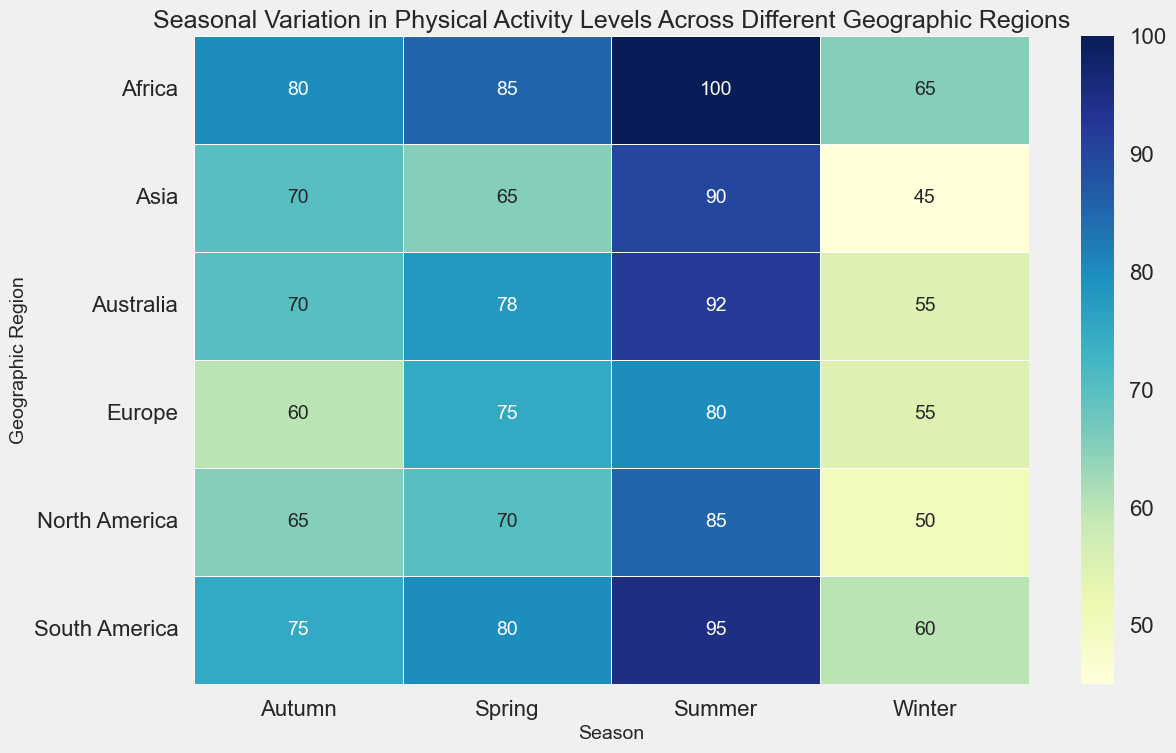Which region has the highest physical activity level in summer? By looking at the heatmap, you can see that the darkest cell in the "Summer" column corresponds to Africa with a value of 100.
Answer: Africa Which region shows the lowest physical activity level in winter? Referring to the heatmap, the lightest cell in the "Winter" column represents Asia with a value of 45.
Answer: Asia What is the average physical activity level in South America across all seasons? The values for South America are: Winter (60), Spring (80), Summer (95), and Autumn (75). Average = (60 + 80 + 95 + 75) / 4 = 310 / 4 = 77.5.
Answer: 77.5 Is the physical activity level in Europe higher in spring or autumn? In Europe, the activity level in spring is 75, while in autumn it is 60. 75 is greater than 60, so it is higher in Spring.
Answer: Spring How much greater is the physical activity level in Africa during summer compared to winter? The activity level in Africa during summer is 100, and in winter is 65. Difference = 100 - 65 = 35.
Answer: 35 Which season exhibits the most uniform physical activity levels across all regions? By examining the heatmap, the colors in the "Spring" column appear the most uniform, indicating similar physical activity levels.
Answer: Spring Rank the geographic regions in ascending order of their physical activity levels during autumn. The autumn values are as follows: North America (65), Europe (60), Asia (70), South America (75), and Africa (80), Australia (70). Ascending order: Europe (60), North America (65), Asia (70), Australia (70), South America (75), and Africa (80).
Answer: Europe, North America, Asia/Australia, South America, Africa What is the total physical activity level in North America across all seasons? The values for North America are: Winter (50), Spring (70), Summer (85), Autumn (65). Total = 50 + 70 + 85 + 65 = 270.
Answer: 270 Between which seasons does Australia see the largest increase in physical activity levels? The values in Australia are: Winter (55), Spring (78), Summer (92), Autumn (70). The largest increase is from Winter (55) to Spring (78), which is 78 - 55 = 23.
Answer: Winter to Spring 